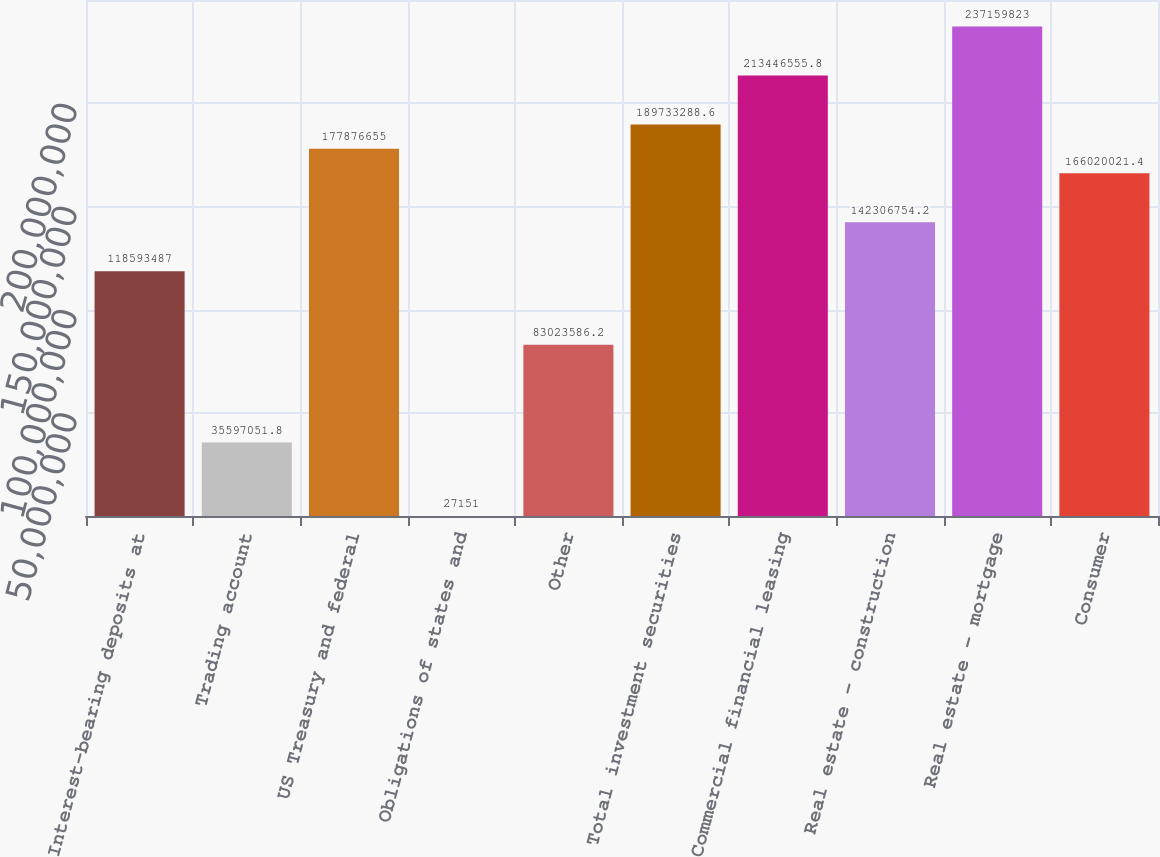<chart> <loc_0><loc_0><loc_500><loc_500><bar_chart><fcel>Interest-bearing deposits at<fcel>Trading account<fcel>US Treasury and federal<fcel>Obligations of states and<fcel>Other<fcel>Total investment securities<fcel>Commercial financial leasing<fcel>Real estate - construction<fcel>Real estate - mortgage<fcel>Consumer<nl><fcel>1.18593e+08<fcel>3.55971e+07<fcel>1.77877e+08<fcel>27151<fcel>8.30236e+07<fcel>1.89733e+08<fcel>2.13447e+08<fcel>1.42307e+08<fcel>2.3716e+08<fcel>1.6602e+08<nl></chart> 